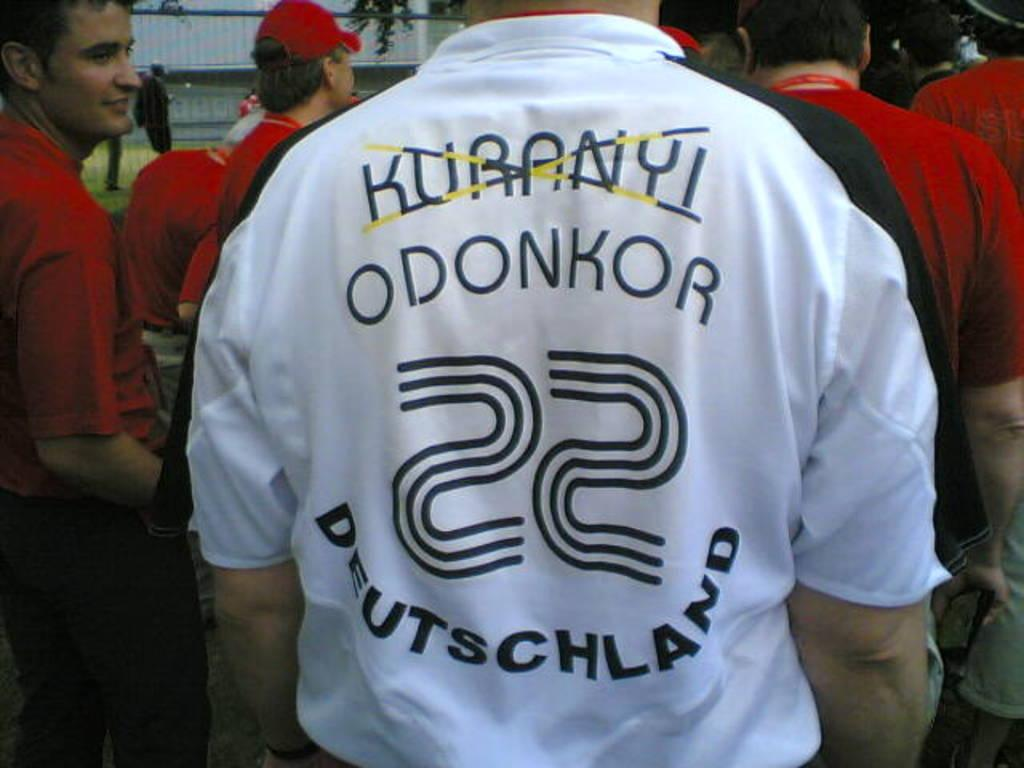<image>
Present a compact description of the photo's key features. A white Deutschland number 22 jersey with two names on it, Odonkor underneath another name crossed out Kuranyi; other men in the background are seen wearing red jerseys. 